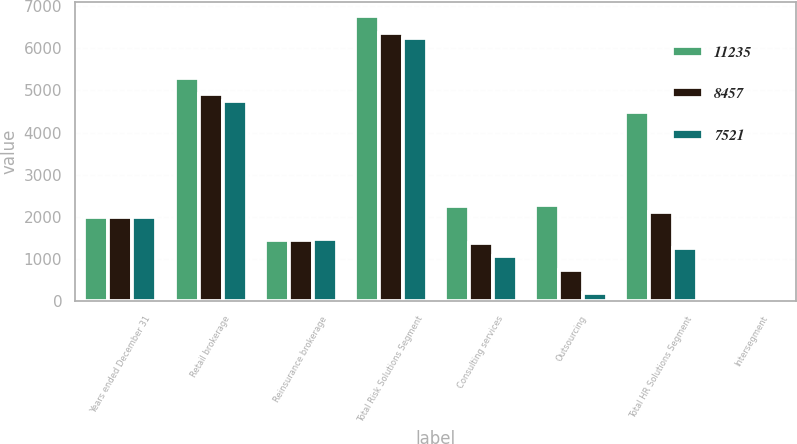Convert chart to OTSL. <chart><loc_0><loc_0><loc_500><loc_500><stacked_bar_chart><ecel><fcel>Years ended December 31<fcel>Retail brokerage<fcel>Reinsurance brokerage<fcel>Total Risk Solutions Segment<fcel>Consulting services<fcel>Outsourcing<fcel>Total HR Solutions Segment<fcel>Intersegment<nl><fcel>11235<fcel>2011<fcel>5303<fcel>1463<fcel>6766<fcel>2251<fcel>2272<fcel>4500<fcel>31<nl><fcel>8457<fcel>2010<fcel>4925<fcel>1444<fcel>6369<fcel>1387<fcel>731<fcel>2110<fcel>22<nl><fcel>7521<fcel>2009<fcel>4747<fcel>1485<fcel>6232<fcel>1075<fcel>191<fcel>1266<fcel>26<nl></chart> 